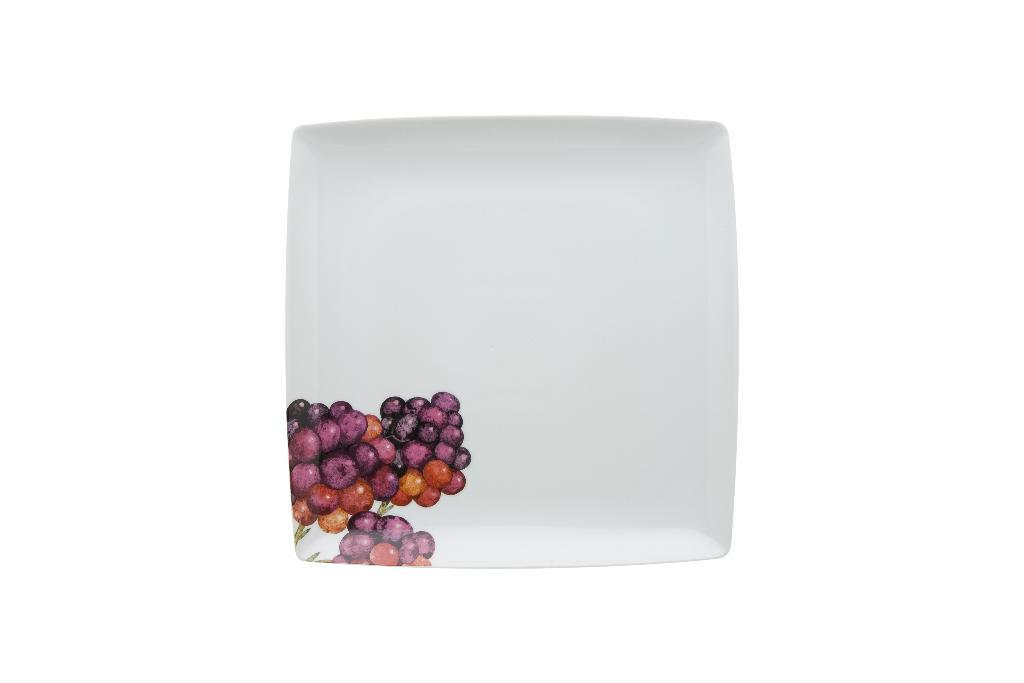What is present on the plate in the image? The plate has a grapes design printed on it. What color is the chalk used to draw the grapes design on the plate? There is no chalk present in the image, as the grapes design is printed on the plate. 